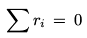Convert formula to latex. <formula><loc_0><loc_0><loc_500><loc_500>\sum r _ { i } \, = \, 0</formula> 